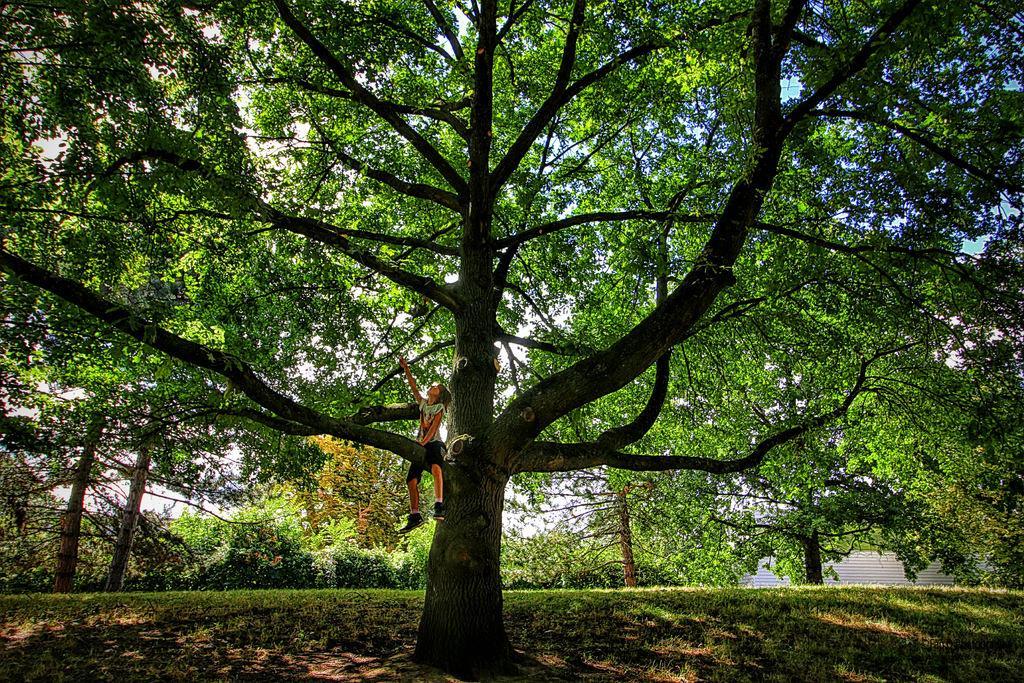Describe this image in one or two sentences. In this image there is grass, plants, trees, a person sitting on the branch of the tree , and in the background there is sky. 